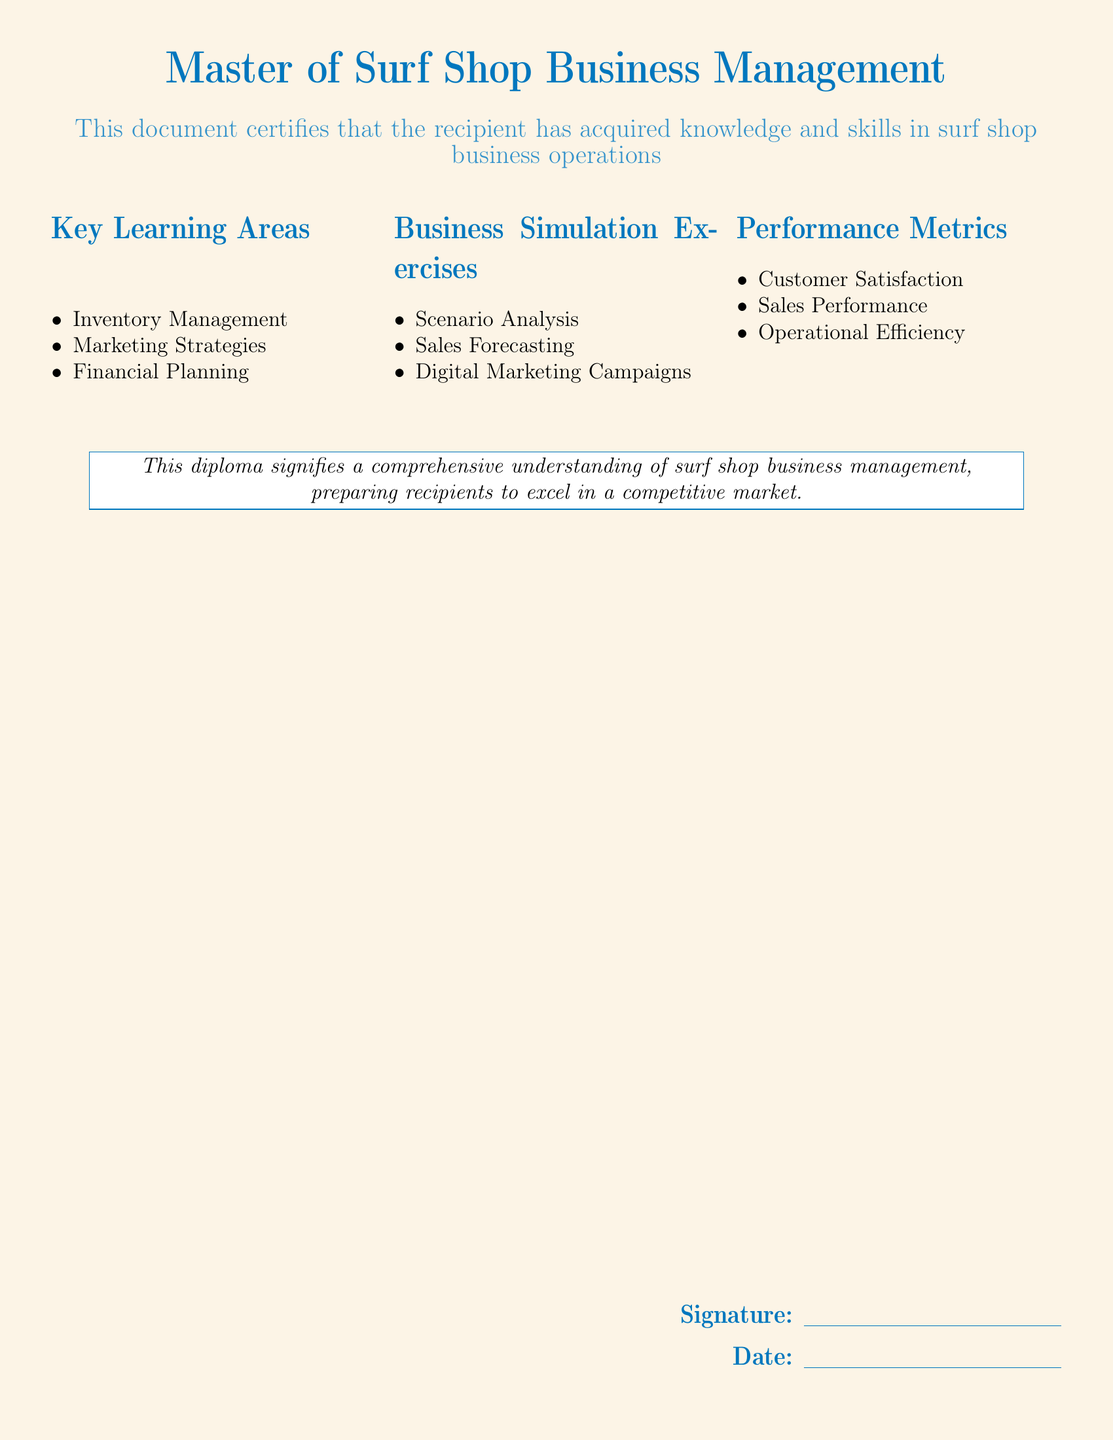What is the title of the diploma? The title of the diploma is prominently displayed at the top of the document.
Answer: Master of Surf Shop Business Management What are the key learning areas listed? The key learning areas are outlined in a specific section of the document.
Answer: Inventory Management, Marketing Strategies, Financial Planning How many business simulation exercises are mentioned? The document lists the number of exercises under the corresponding section.
Answer: Three What is the color of the page background? The document indicates the background color by its layout and design.
Answer: Sandy yellow What performance metric is related to customer experience? Customer satisfaction is listed as a performance metric in the document.
Answer: Customer Satisfaction What does the diploma signify? The document provides a summarizing statement about what the diploma represents.
Answer: A comprehensive understanding of surf shop business management Who signs the diploma? The document has a section for a signature to validate it.
Answer: The instructor (implied by the signature line) What does the signature section include? The signature section includes two distinct fields as seen in the document.
Answer: Signature and Date 